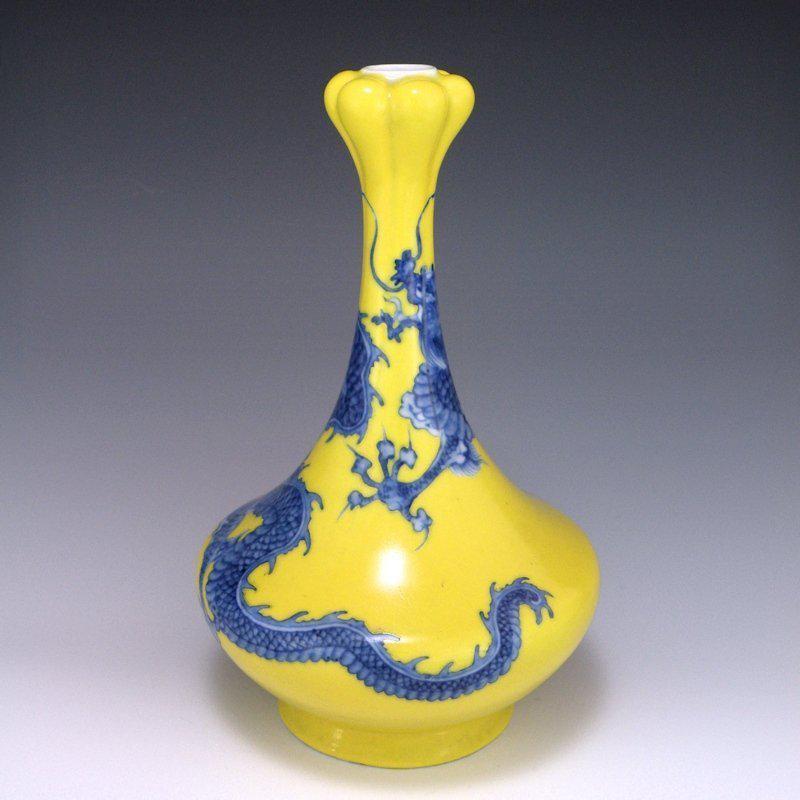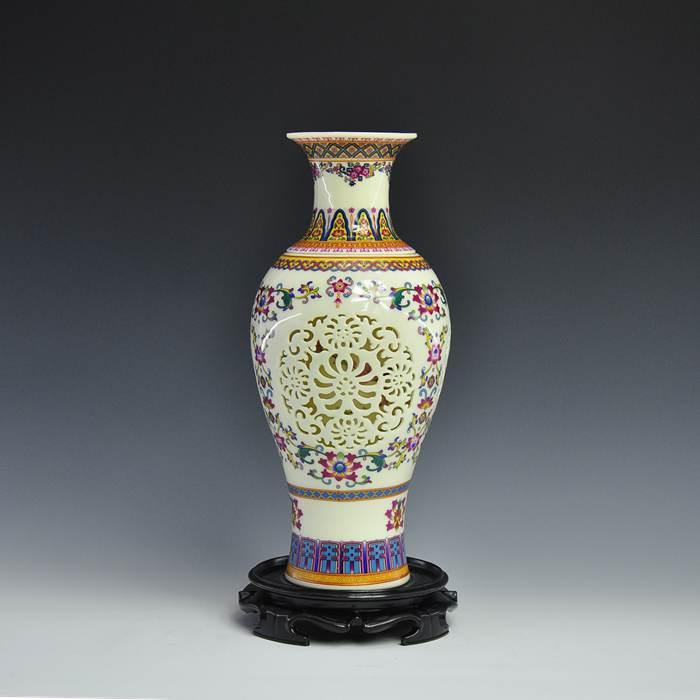The first image is the image on the left, the second image is the image on the right. Examine the images to the left and right. Is the description "There is a vase with a lot of blue on it with a wide bottom and a skinny neck at the top." accurate? Answer yes or no. Yes. 